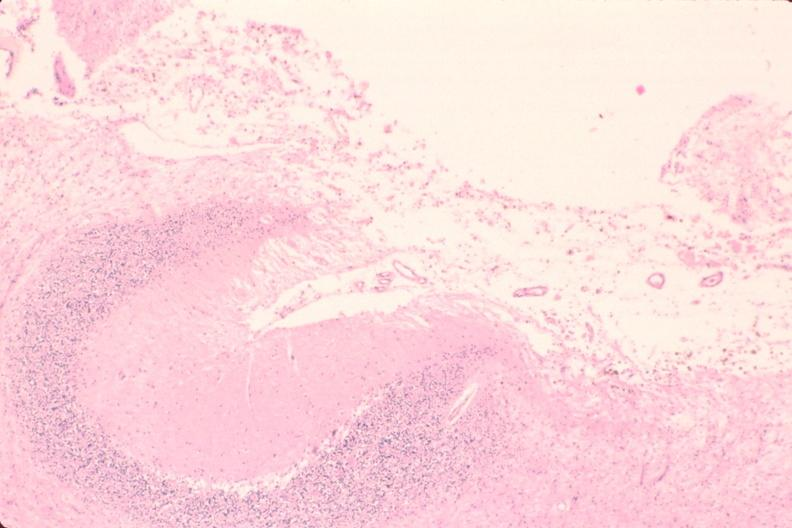does this image show brain, encephalomalasia?
Answer the question using a single word or phrase. Yes 